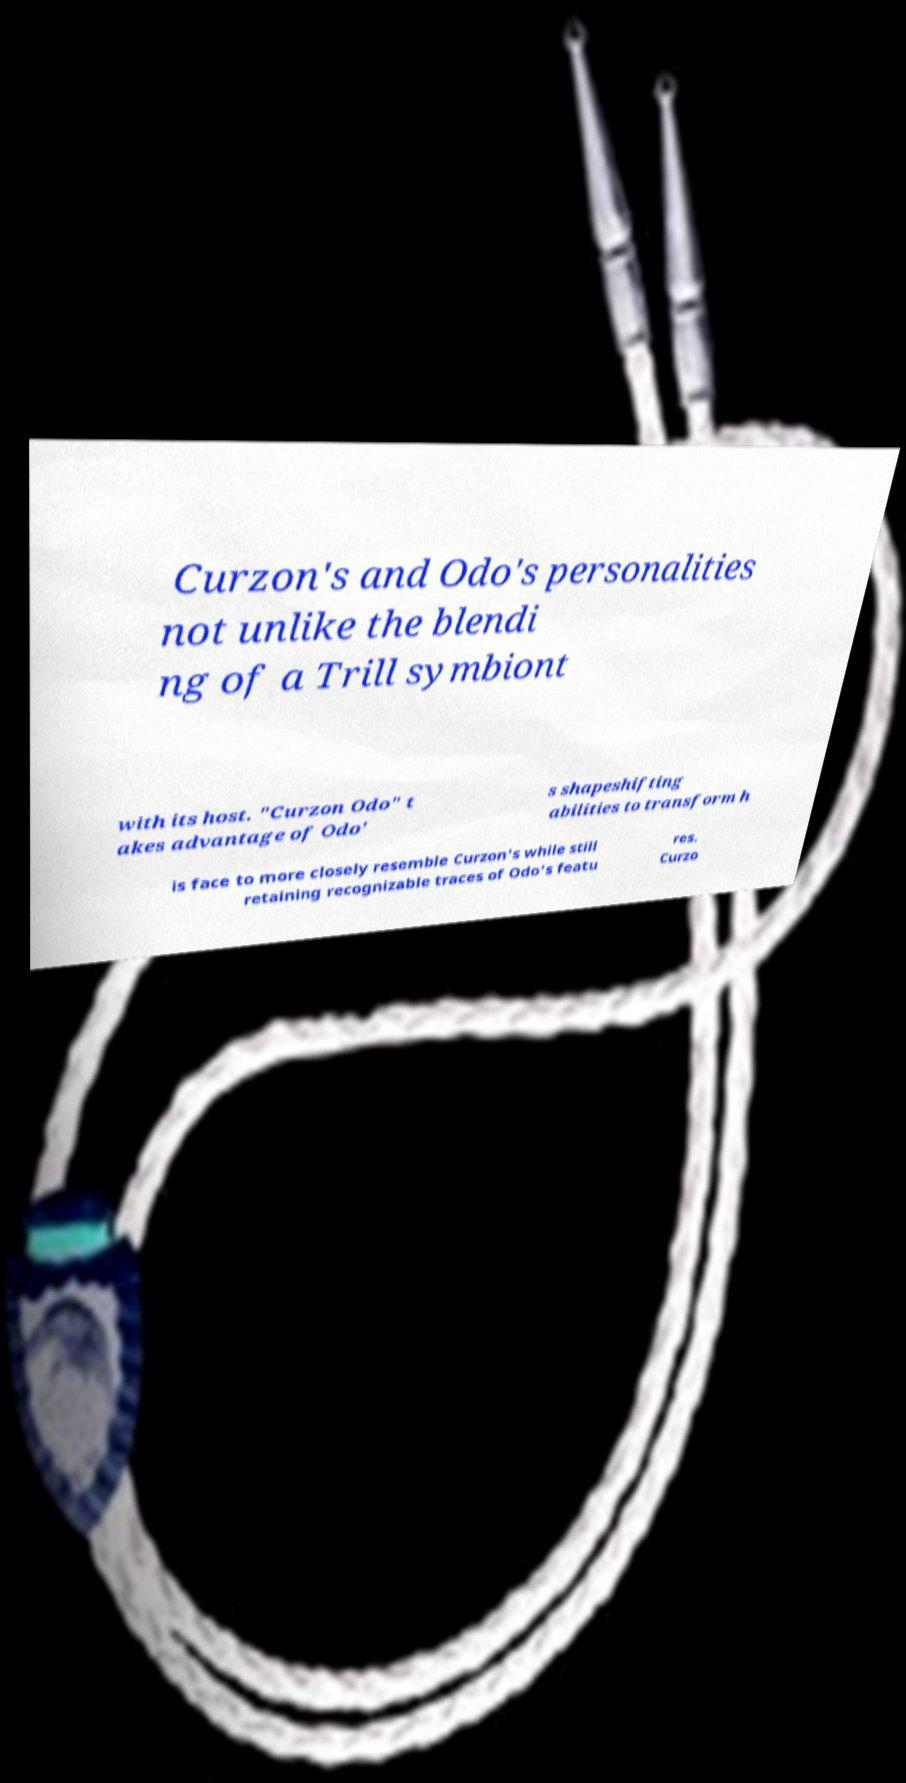What messages or text are displayed in this image? I need them in a readable, typed format. Curzon's and Odo's personalities not unlike the blendi ng of a Trill symbiont with its host. "Curzon Odo" t akes advantage of Odo' s shapeshifting abilities to transform h is face to more closely resemble Curzon's while still retaining recognizable traces of Odo's featu res. Curzo 